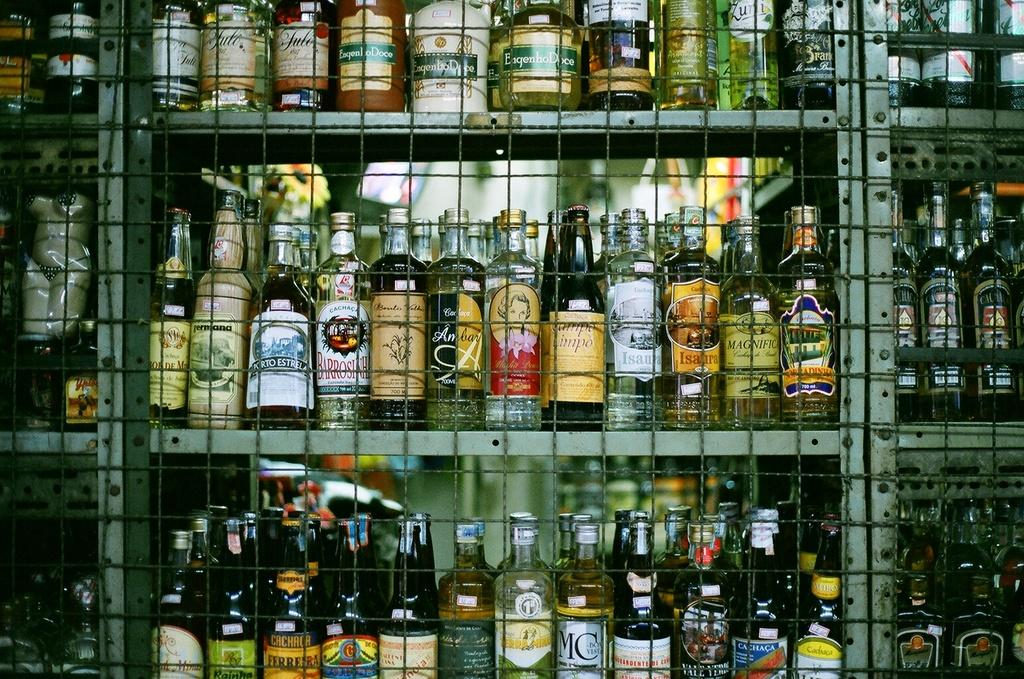Provide a one-sentence caption for the provided image. Rows of liquor like Cachaca on shelves in a store. 